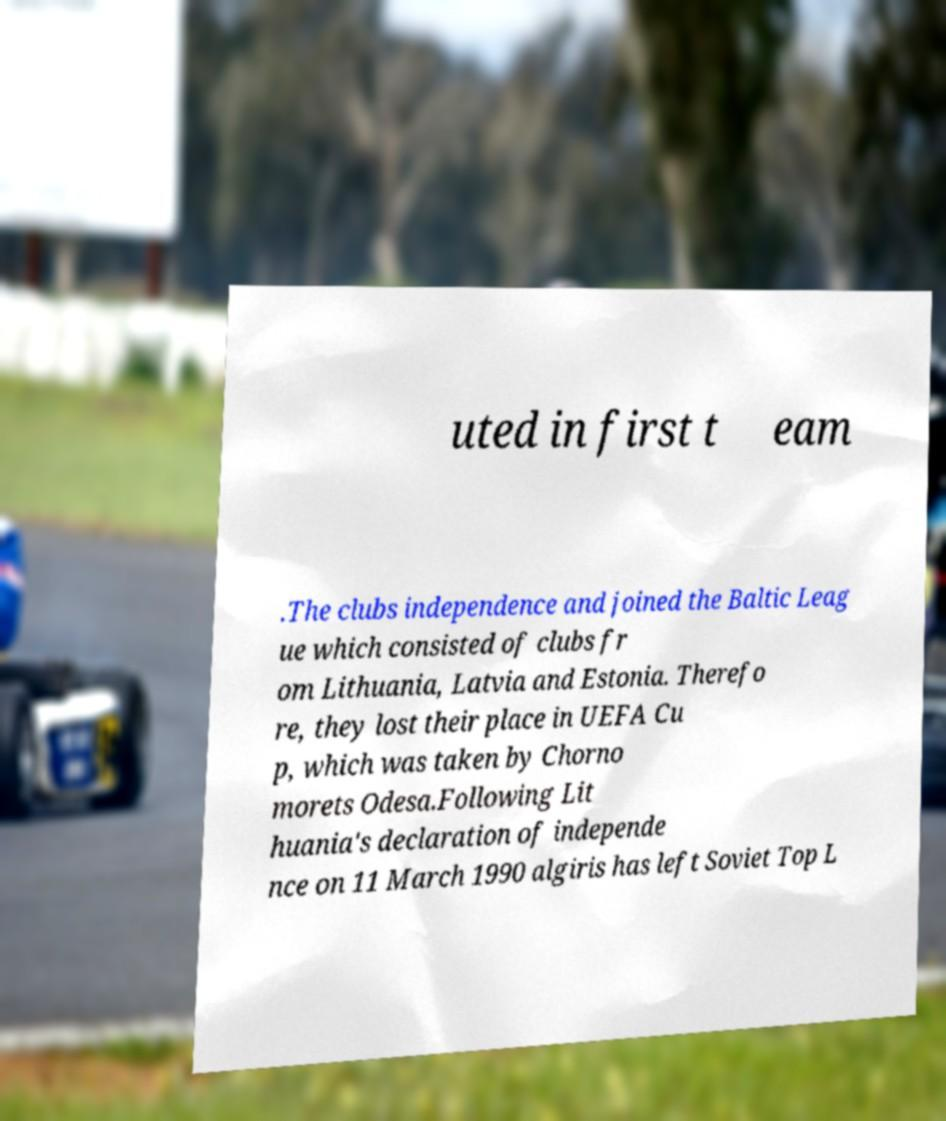There's text embedded in this image that I need extracted. Can you transcribe it verbatim? uted in first t eam .The clubs independence and joined the Baltic Leag ue which consisted of clubs fr om Lithuania, Latvia and Estonia. Therefo re, they lost their place in UEFA Cu p, which was taken by Chorno morets Odesa.Following Lit huania's declaration of independe nce on 11 March 1990 algiris has left Soviet Top L 